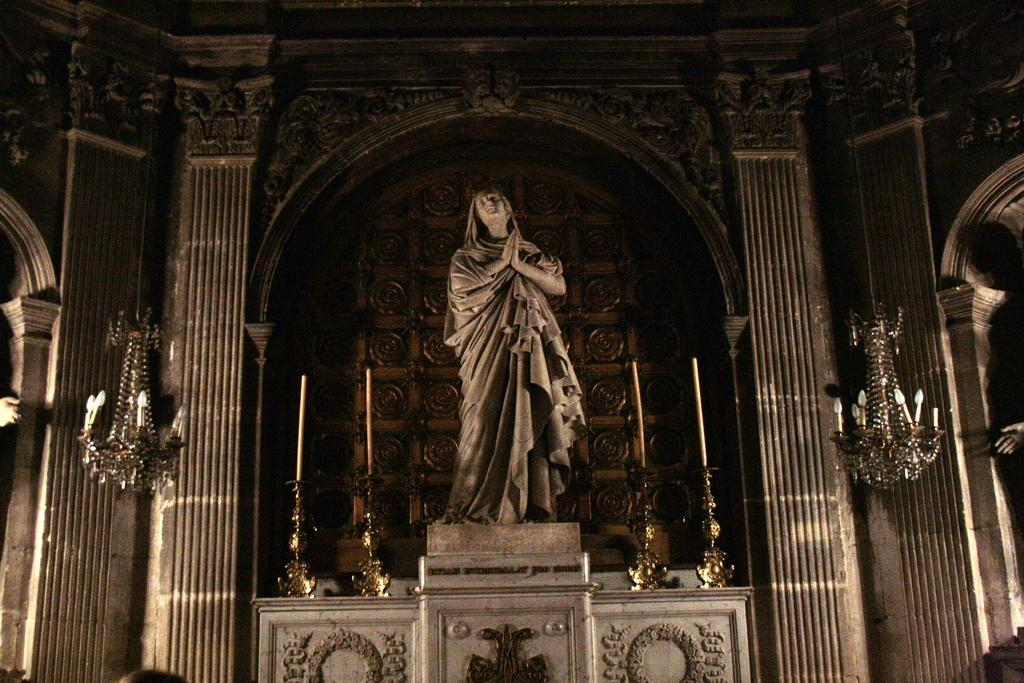What type of building is shown in the image? The image is an inside view of a church. What kind of artwork can be seen in the image? There is a sculpture in the image. What architectural feature is present in the image? There are pillars in the image. What is used to illuminate the interior of the church in the image? There are lights in the image. What other objects can be seen in the image besides the sculpture and pillars? There are other objects in the image. Can you see a rod being used to plough a mountain in the image? No, there is no rod, plough, or mountain present in the image. The image is an inside view of a church with a sculpture, pillars, lights, and other objects. 